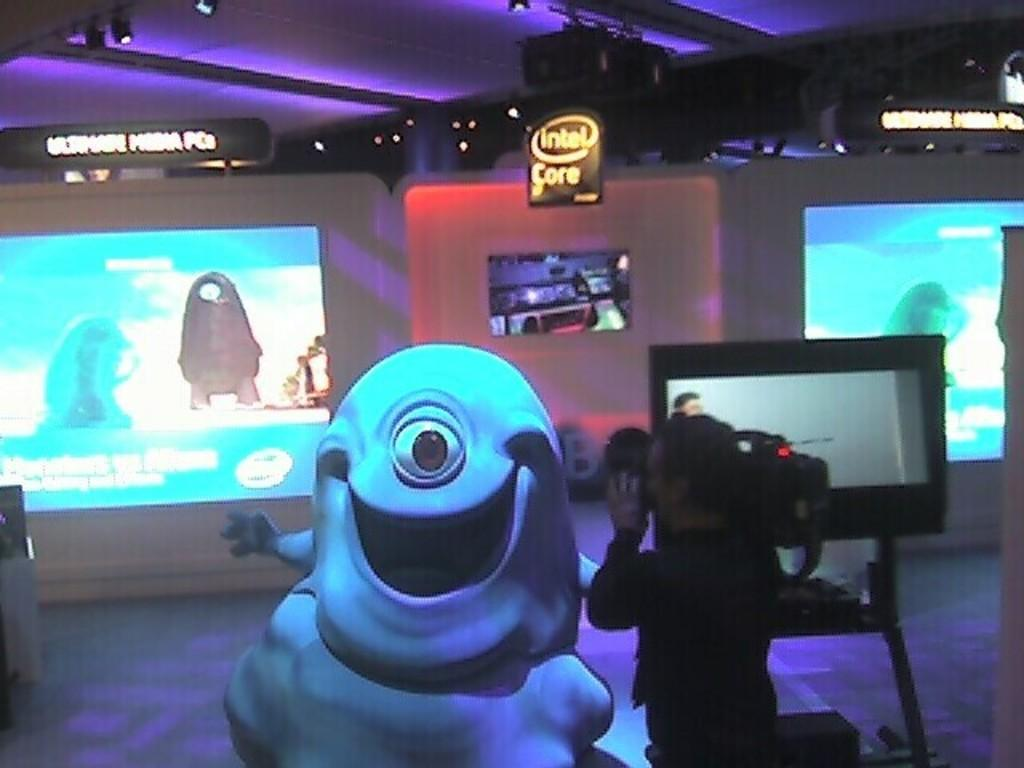<image>
Create a compact narrative representing the image presented. A man with a video camera taping Bob from the movie Monsters vs. Aliens. 